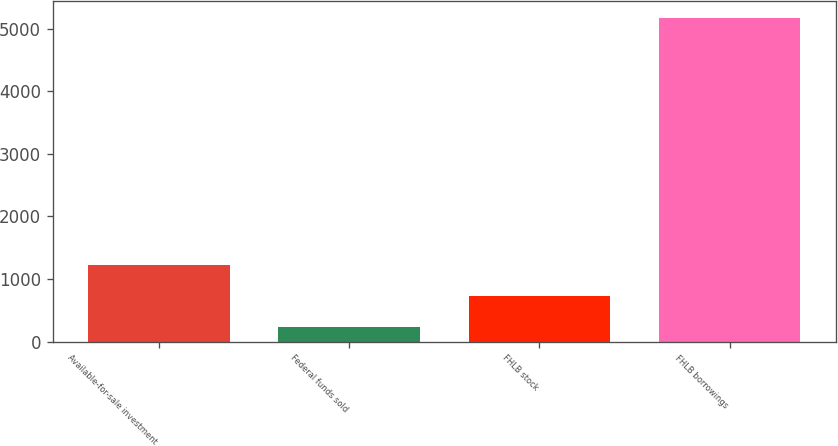Convert chart to OTSL. <chart><loc_0><loc_0><loc_500><loc_500><bar_chart><fcel>Available-for-sale investment<fcel>Federal funds sold<fcel>FHLB stock<fcel>FHLB borrowings<nl><fcel>1222.4<fcel>234<fcel>728.2<fcel>5176<nl></chart> 